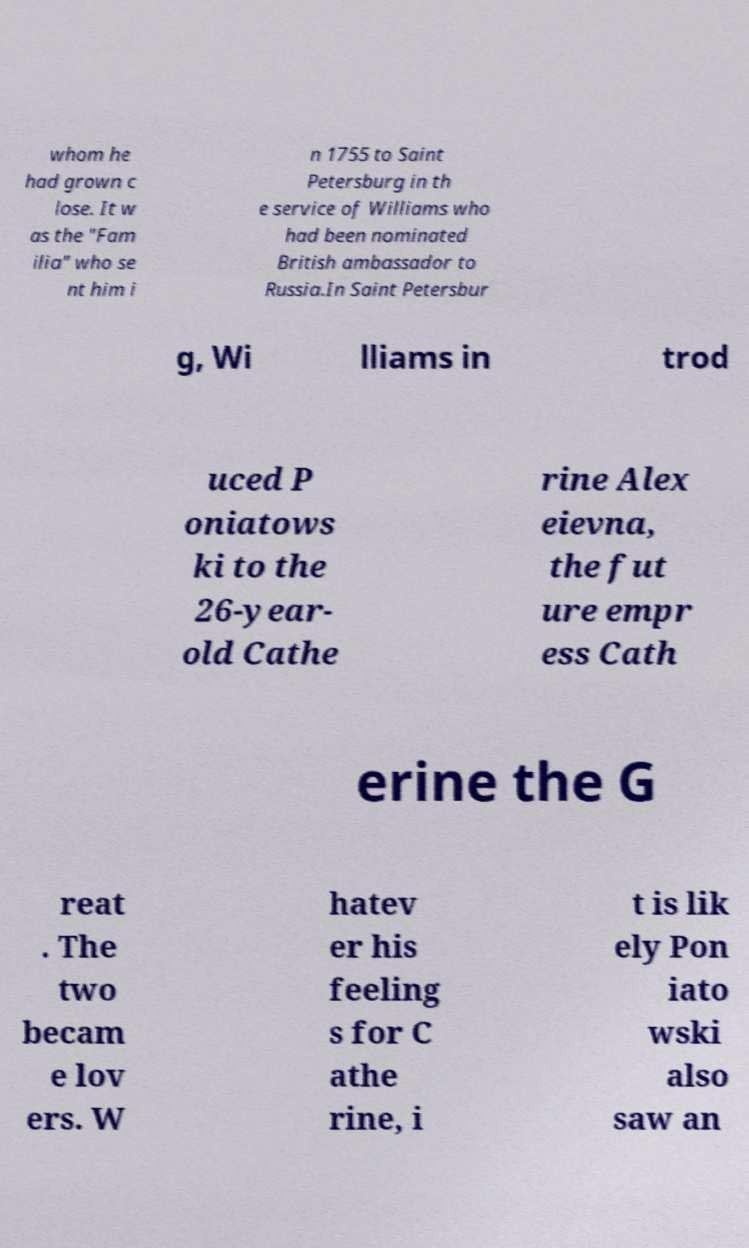I need the written content from this picture converted into text. Can you do that? whom he had grown c lose. It w as the "Fam ilia" who se nt him i n 1755 to Saint Petersburg in th e service of Williams who had been nominated British ambassador to Russia.In Saint Petersbur g, Wi lliams in trod uced P oniatows ki to the 26-year- old Cathe rine Alex eievna, the fut ure empr ess Cath erine the G reat . The two becam e lov ers. W hatev er his feeling s for C athe rine, i t is lik ely Pon iato wski also saw an 